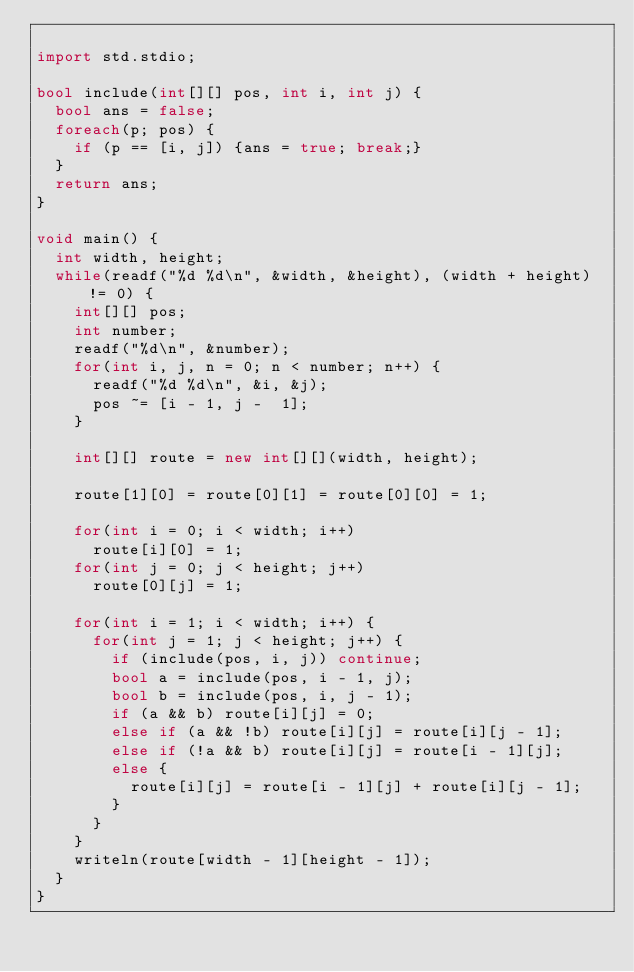Convert code to text. <code><loc_0><loc_0><loc_500><loc_500><_D_>
import std.stdio;

bool include(int[][] pos, int i, int j) {
  bool ans = false;
  foreach(p; pos) {
    if (p == [i, j]) {ans = true; break;}
  }
  return ans;
}

void main() {
  int width, height;
  while(readf("%d %d\n", &width, &height), (width + height) != 0) {
    int[][] pos;
    int number;
    readf("%d\n", &number);
    for(int i, j, n = 0; n < number; n++) {
      readf("%d %d\n", &i, &j);
      pos ~= [i - 1, j -  1];
    }

    int[][] route = new int[][](width, height);

    route[1][0] = route[0][1] = route[0][0] = 1;

    for(int i = 0; i < width; i++)
      route[i][0] = 1;
    for(int j = 0; j < height; j++)
      route[0][j] = 1;
  
    for(int i = 1; i < width; i++) {
      for(int j = 1; j < height; j++) {
        if (include(pos, i, j)) continue;
        bool a = include(pos, i - 1, j);
        bool b = include(pos, i, j - 1);
        if (a && b) route[i][j] = 0;
        else if (a && !b) route[i][j] = route[i][j - 1];
        else if (!a && b) route[i][j] = route[i - 1][j];
        else {
          route[i][j] = route[i - 1][j] + route[i][j - 1];
        }
      }
    }
    writeln(route[width - 1][height - 1]);
  }
}</code> 